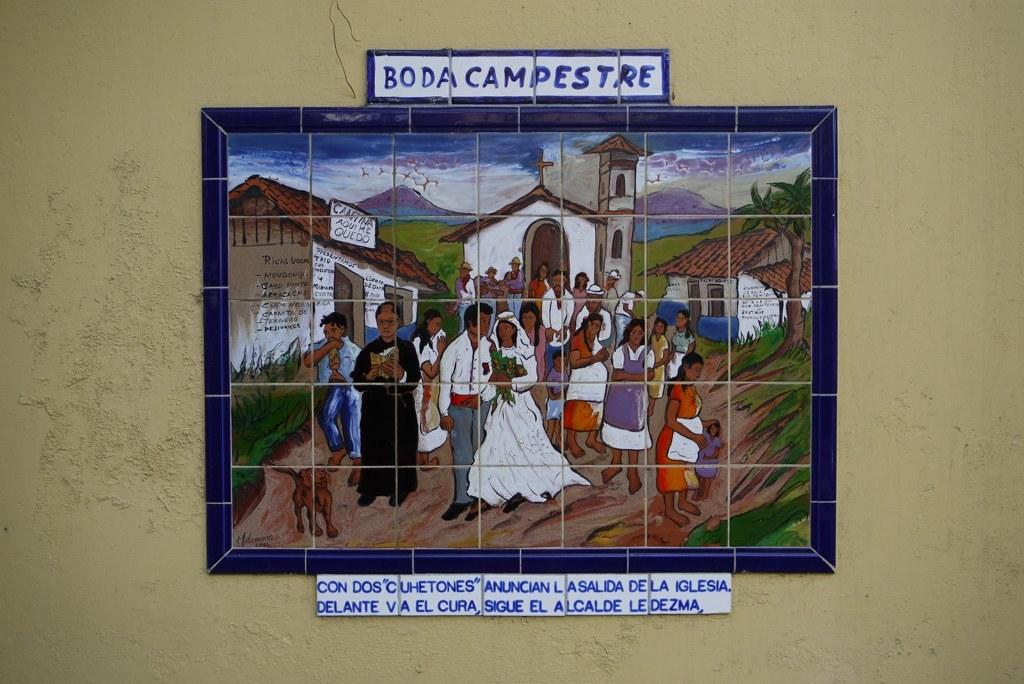<image>
Render a clear and concise summary of the photo. A painting made up of different tiles is titled "Boda Campestre" 